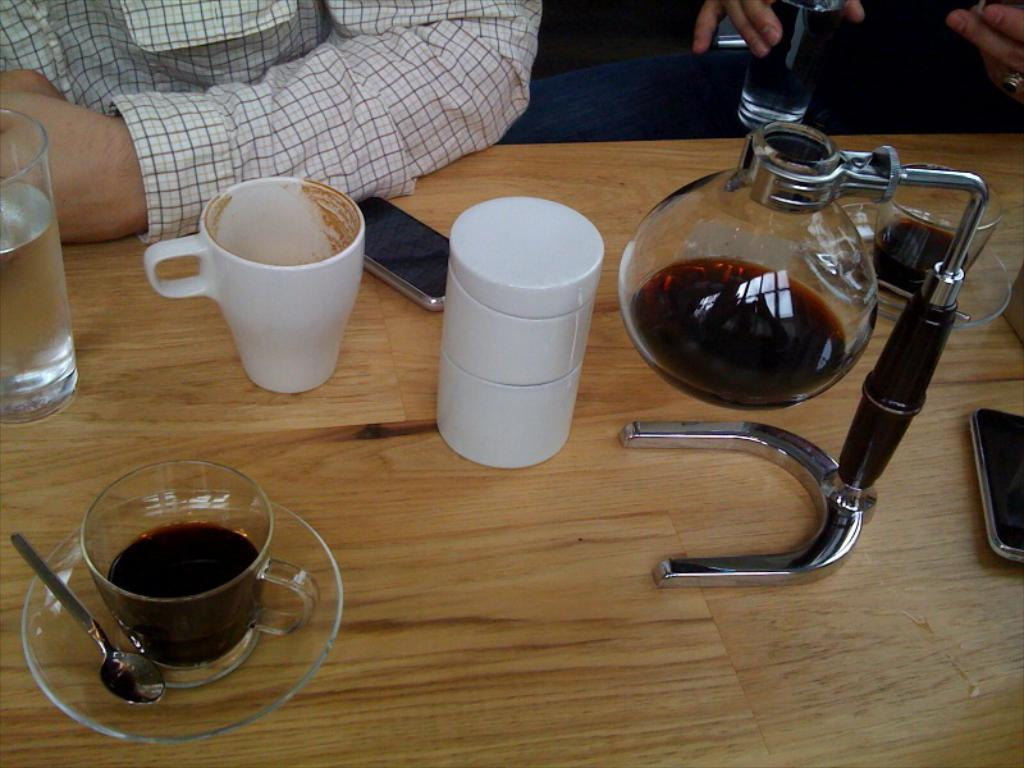What part of a person can be seen in the image? A person's hand is visible in the image. What type of table are the objects placed on? The objects are on a wooden table. What items are used for drinking in the image? There are cups, glasses, and a kettle in the image. What items are used for eating in the image? There are spoons and saucers in the image. What electronic devices are present in the image? There are mobile phones in the image. What type of bird can be seen sitting on the wooden table in the image? There is no bird present in the image; only a person's hand, cups, saucers, spoons, glasses, a kettle, and mobile phones are visible. What stationery item is being used by the person in the image? There is no pencil or any other stationery item visible in the image. 